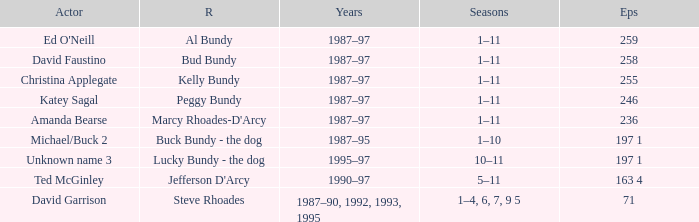How many years did the role of Steve Rhoades last? 1987–90, 1992, 1993, 1995. 